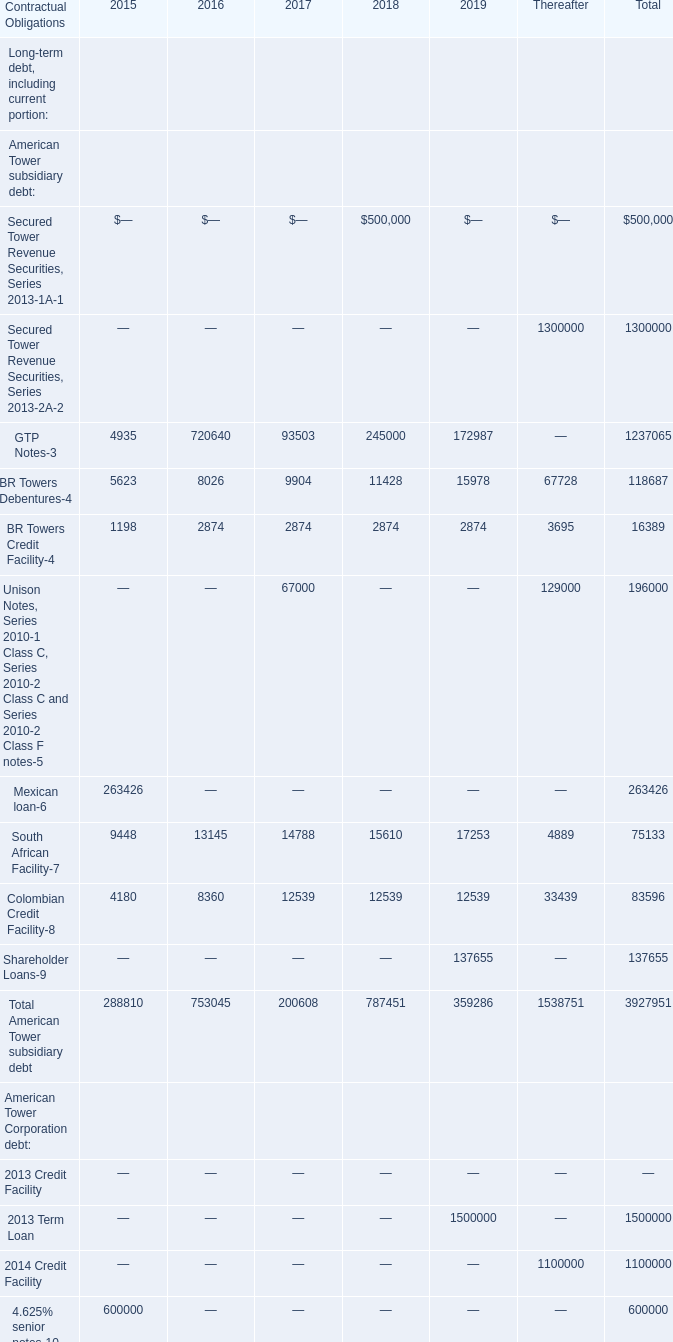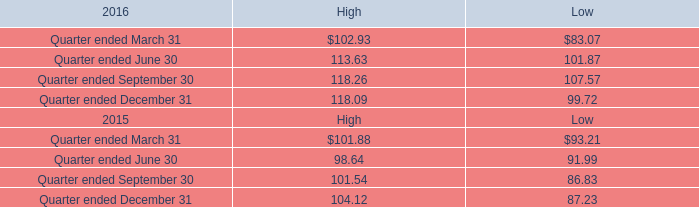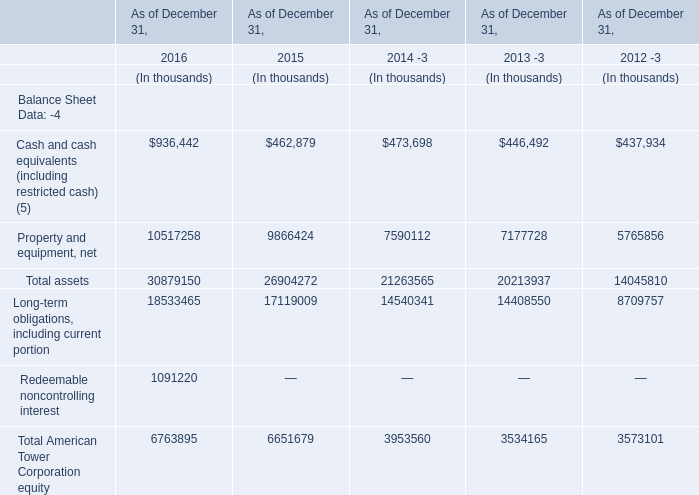what is the average number of shares per registered holder as of february 17 , 2017? 
Computations: (427195037 / 153)
Answer: 2792124.42484. 